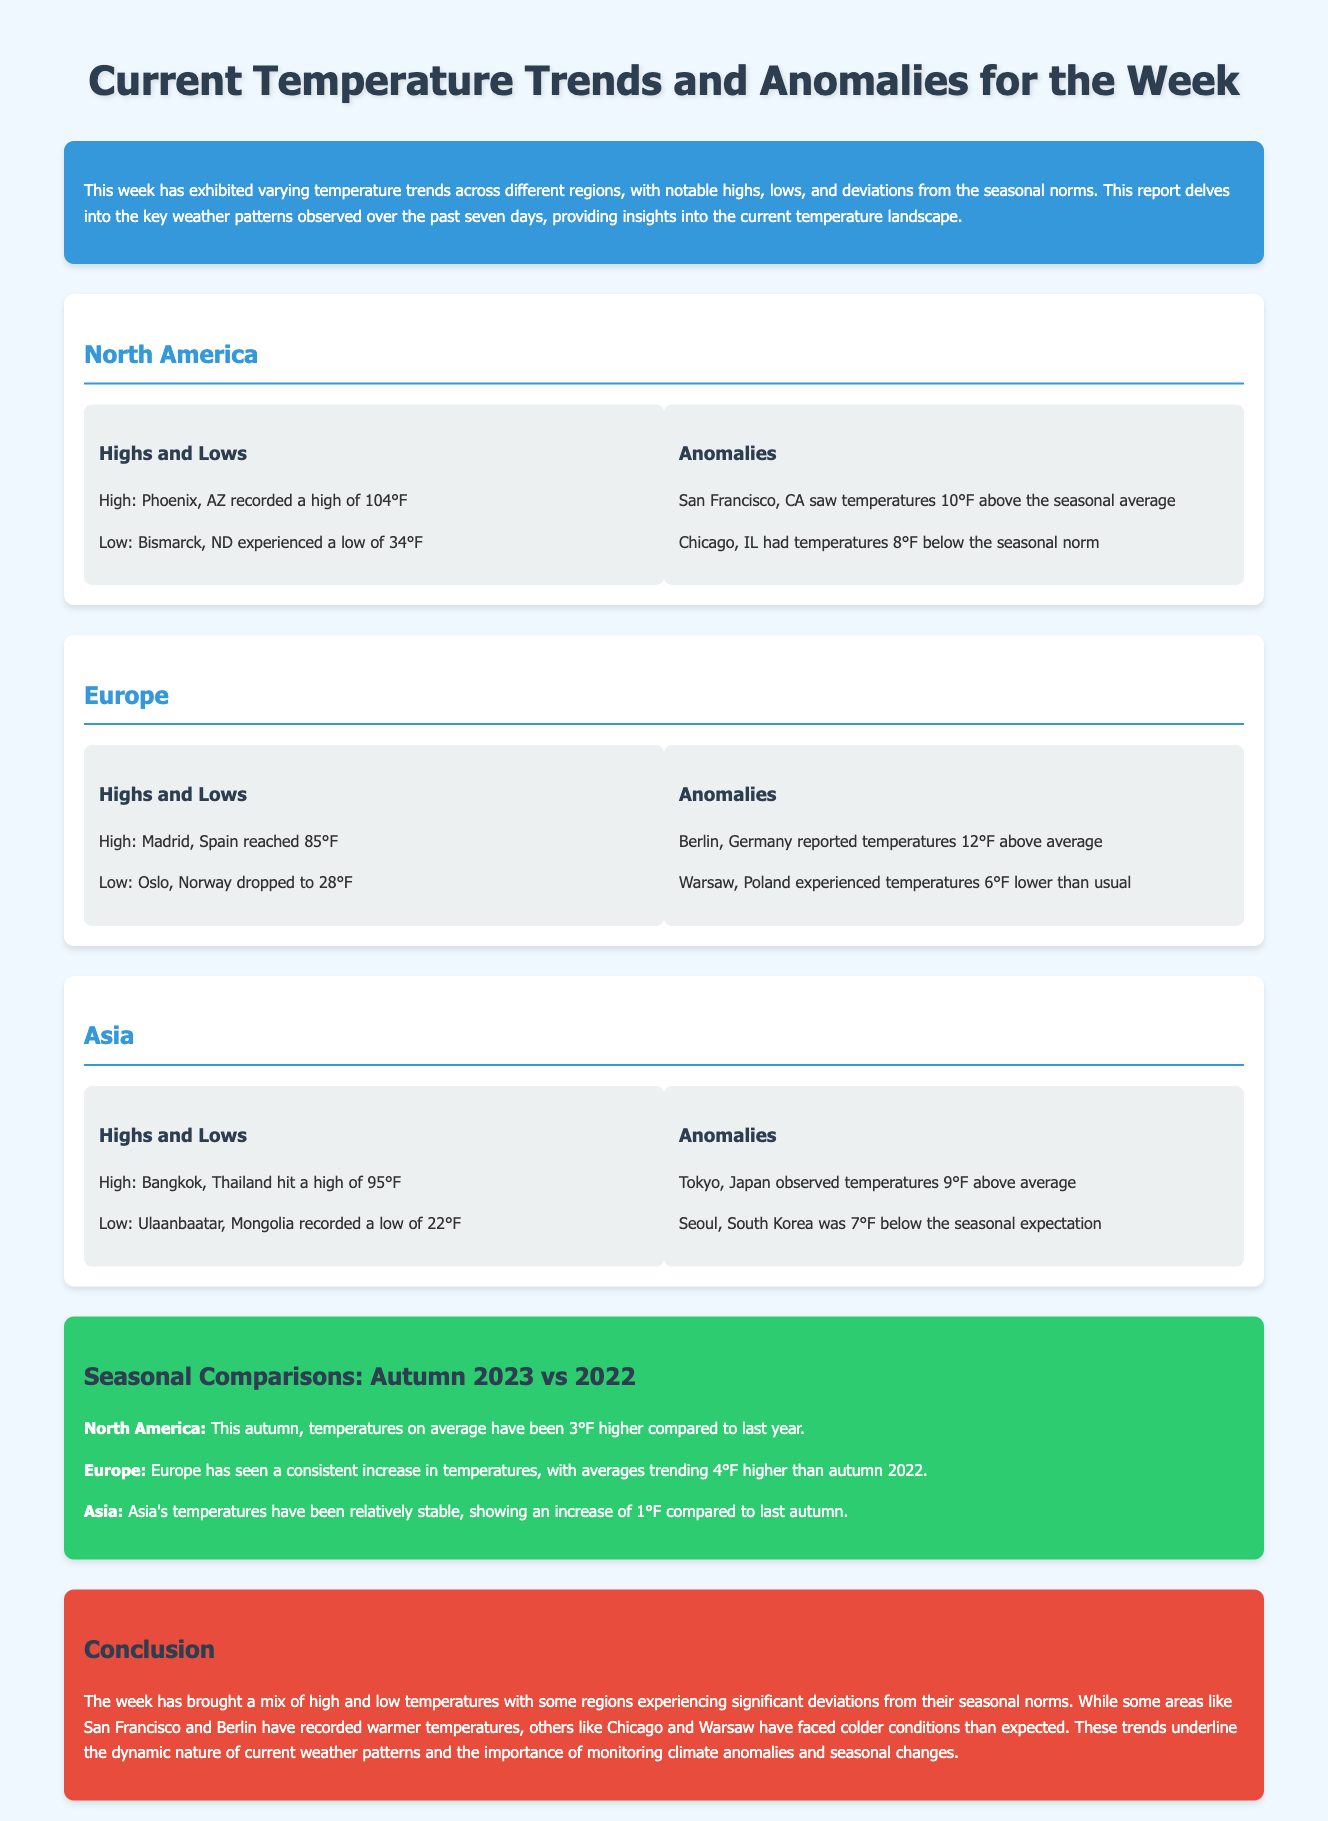What was the highest temperature recorded in North America? The highest temperature recorded in North America was 104°F in Phoenix, AZ.
Answer: 104°F What was the lowest temperature recorded in Europe? The lowest temperature recorded in Europe was 28°F in Oslo, Norway.
Answer: 28°F How much above the seasonal average was San Francisco, CA? San Francisco, CA saw temperatures 10°F above the seasonal average.
Answer: 10°F Which region experienced temperatures 6°F lower than usual? Warsaw, Poland experienced temperatures 6°F lower than usual.
Answer: Warsaw, Poland What is the average temperature increase in North America compared to last year? North America has been 3°F higher compared to last year in autumn.
Answer: 3°F How many degrees below the seasonal expectation was Seoul, South Korea? Seoul, South Korea was 7°F below the seasonal expectation.
Answer: 7°F What was the high temperature recorded in Asia? The high temperature recorded in Asia was 95°F in Bangkok, Thailand.
Answer: 95°F In which region did Berlin report temperatures 12°F above average? Berlin, Germany reported temperatures 12°F above average in Europe.
Answer: Europe What is the primary theme of this document? The primary theme of this document is current temperature trends and anomalies for the week.
Answer: Temperature trends and anomalies 